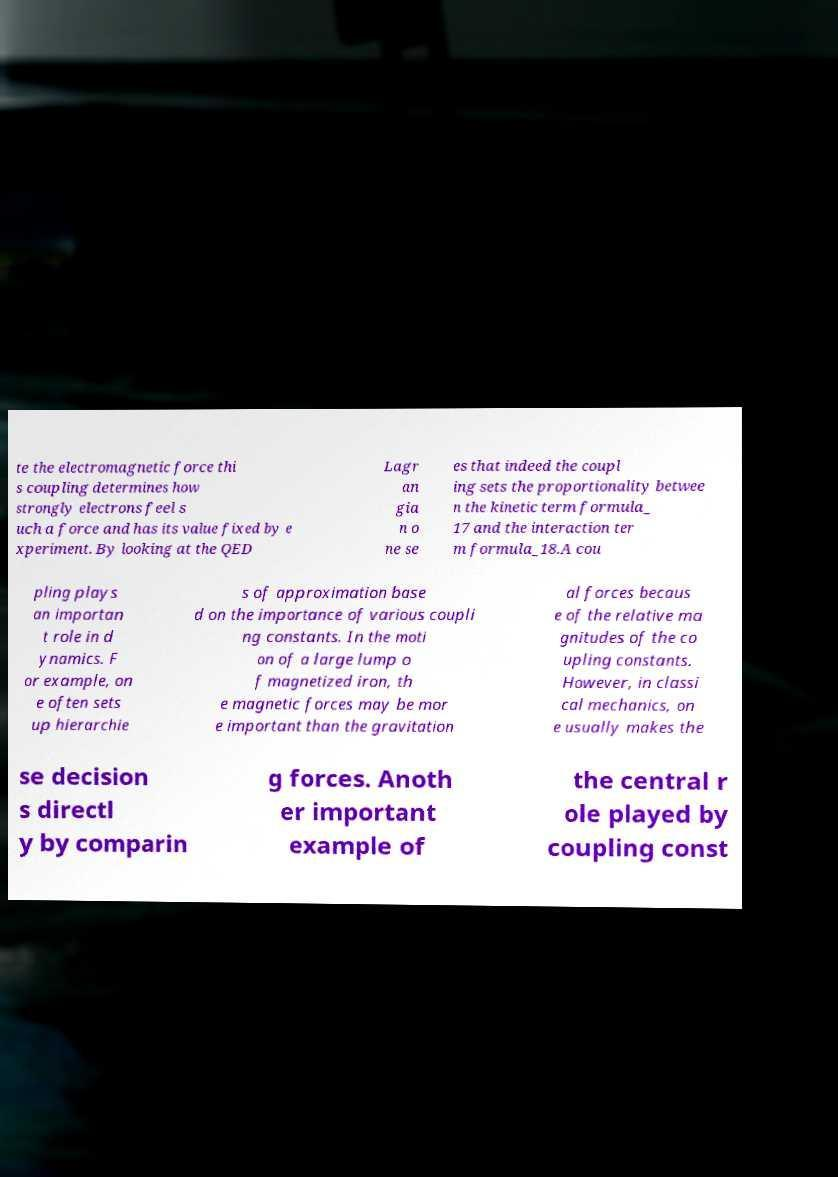Could you extract and type out the text from this image? te the electromagnetic force thi s coupling determines how strongly electrons feel s uch a force and has its value fixed by e xperiment. By looking at the QED Lagr an gia n o ne se es that indeed the coupl ing sets the proportionality betwee n the kinetic term formula_ 17 and the interaction ter m formula_18.A cou pling plays an importan t role in d ynamics. F or example, on e often sets up hierarchie s of approximation base d on the importance of various coupli ng constants. In the moti on of a large lump o f magnetized iron, th e magnetic forces may be mor e important than the gravitation al forces becaus e of the relative ma gnitudes of the co upling constants. However, in classi cal mechanics, on e usually makes the se decision s directl y by comparin g forces. Anoth er important example of the central r ole played by coupling const 